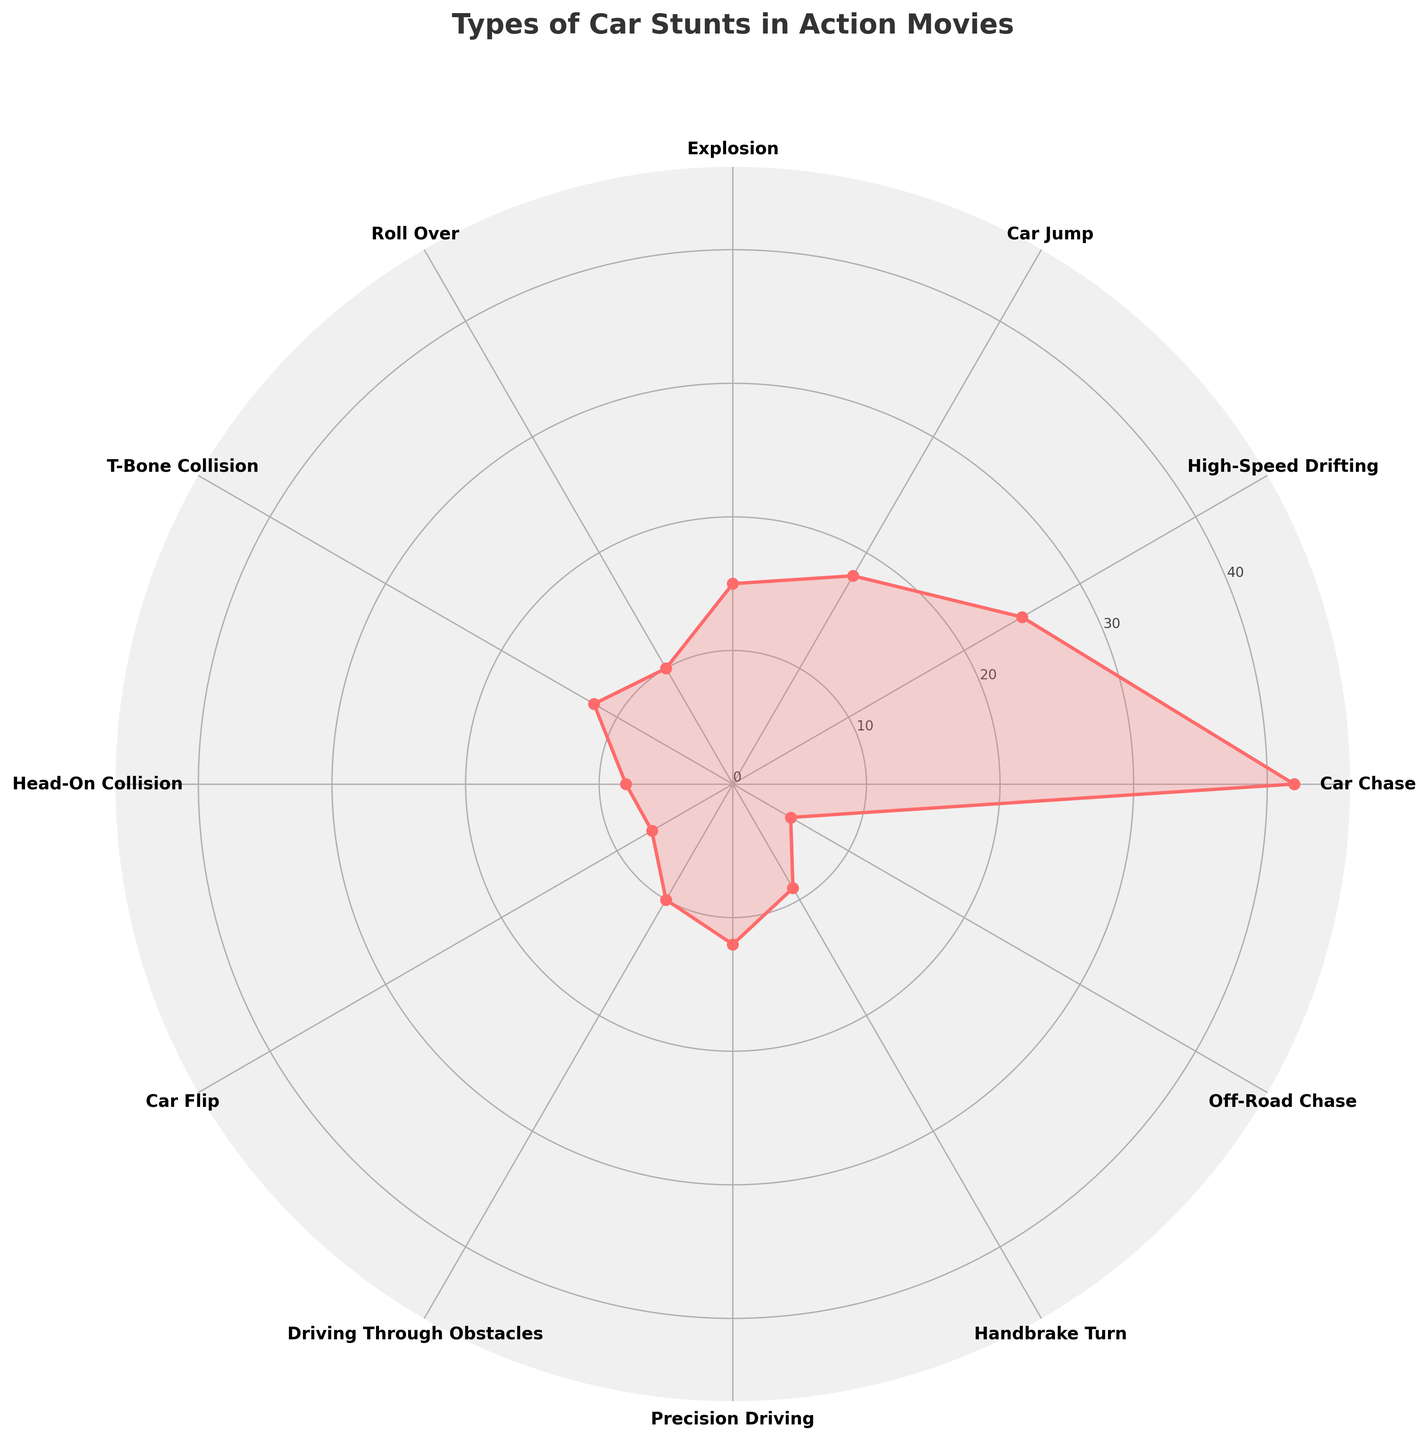what is the most common type of car stunt performed in action films according to the rose chart? The most prominent spoke on the rose chart, which extends the furthest from the center, represents the 'Car Chase' stunt with a frequency of 42.
Answer: Car Chase How many types of car stunts are shown in the chart? There are 12 unique stunts listed on the rose chart's axes, each labeled at the ends of the spokes.
Answer: 12 Which type of car stunt has a frequency of 7? Following the spokes in the rose chart to identify the value of 7, we see the corresponding label is 'Car Flip'.
Answer: Car Flip What is the combined frequency of 'High-Speed Drifting' and 'Explosion' stunts? 'High-Speed Drifting' has a frequency of 25, and 'Explosion' has a frequency of 15. Adding these together: 25 + 15 = 40.
Answer: 40 How does the frequency of 'Car Jump' compare to 'Roll Over'? The frequency of 'Car Jump' is 18, while 'Roll Over' is 10. Comparing these values, 18 is greater than 10.
Answer: 'Car Jump' is greater Which stunts have a frequency of less than 10? Examining the spokes extending less than 10 units from the center, the stunts are 'Head-On Collision,' 'Car Flip,' and 'Off-Road Chase.'
Answer: Head-On Collision, Car Flip, Off-Road Chase What title is given to the rose chart? The title is located above the chart and reads 'Types of Car Stunts in Action Movies'.
Answer: Types of Car Stunts in Action Movies What is the cumulative frequency of all car stunts? Summing up the individual frequencies: 42 + 25 + 18 + 15 + 10 + 12 + 8 + 7 + 10 + 12 + 9 + 5 = 173.
Answer: 173 How does 'T-Bone Collision' frequency compare with 'Precision Driving'? Both 'T-Bone Collision' and 'Precision Driving' have frequencies of 12.
Answer: Equal What is the median frequency of the car stunts? Sorting the frequencies in ascending order: [5, 7, 8, 9, 10, 10, 12, 12, 15, 18, 25, 42], the middle two numbers are 10 and 12. Therefore, the median is the average of these two numbers: (10 + 12) / 2 = 11.
Answer: 11 